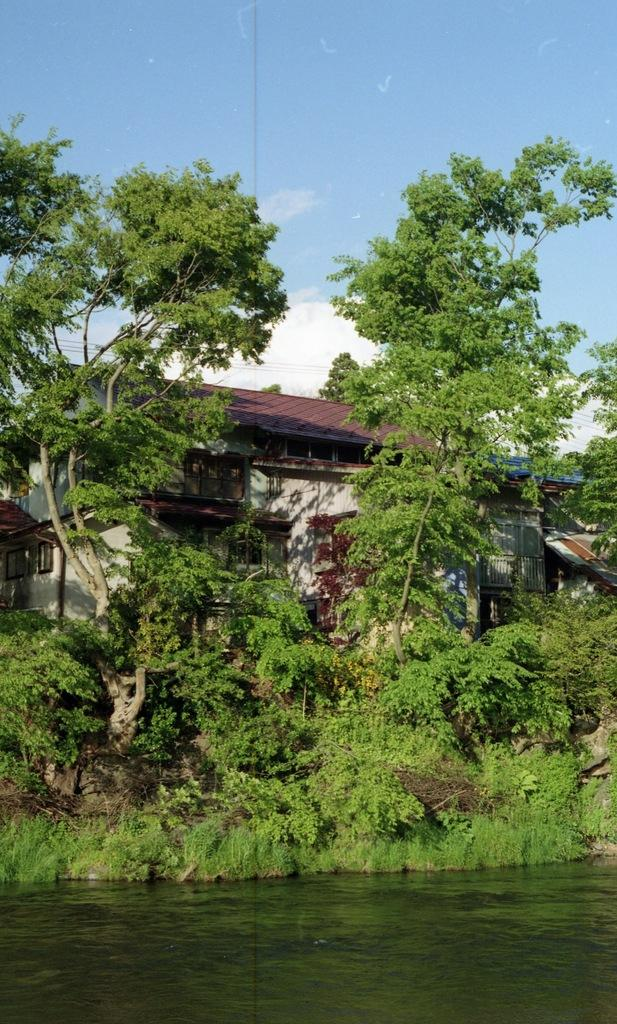What is the primary element present in the image? There is water in the image. What other natural elements can be seen in the image? There are plants and trees in the image. What type of structure is visible in the image? There is a house in the image. What can be seen in the background of the image? The sky is visible in the background of the image, and there are clouds in the sky. What type of mitten is being used to guide the surprise in the image? There is no mitten, guide, or surprise present in the image. 